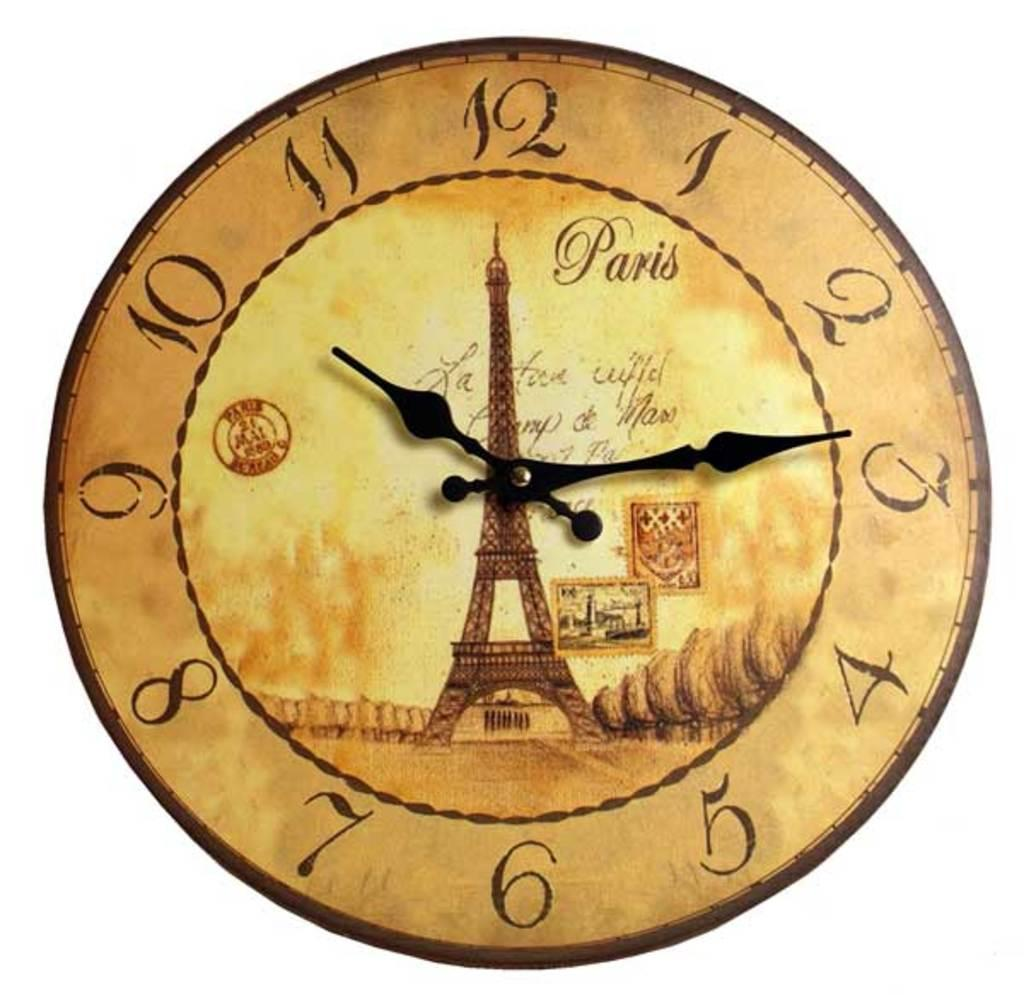<image>
Summarize the visual content of the image. the numbers 1 to 12 on a Paris clock 